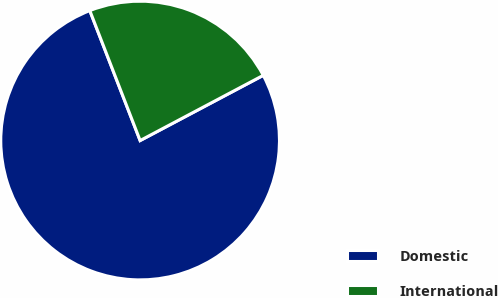<chart> <loc_0><loc_0><loc_500><loc_500><pie_chart><fcel>Domestic<fcel>International<nl><fcel>76.87%<fcel>23.13%<nl></chart> 